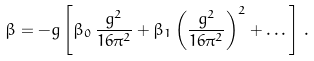Convert formula to latex. <formula><loc_0><loc_0><loc_500><loc_500>\beta = - g \left [ \beta _ { 0 } \, \frac { g ^ { 2 } } { 1 6 \pi ^ { 2 } } + \beta _ { 1 } \left ( \frac { g ^ { 2 } } { 1 6 \pi ^ { 2 } } \right ) ^ { 2 } + \dots \right ] \, .</formula> 